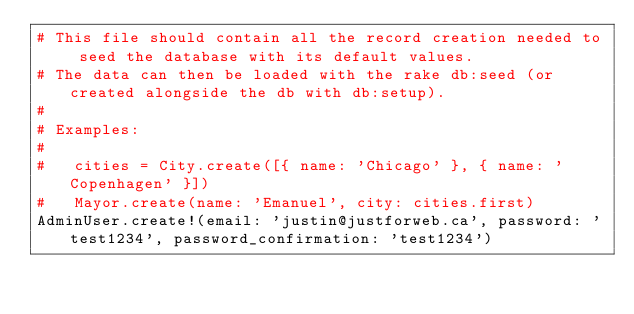Convert code to text. <code><loc_0><loc_0><loc_500><loc_500><_Ruby_># This file should contain all the record creation needed to seed the database with its default values.
# The data can then be loaded with the rake db:seed (or created alongside the db with db:setup).
#
# Examples:
#
#   cities = City.create([{ name: 'Chicago' }, { name: 'Copenhagen' }])
#   Mayor.create(name: 'Emanuel', city: cities.first)
AdminUser.create!(email: 'justin@justforweb.ca', password: 'test1234', password_confirmation: 'test1234')
</code> 